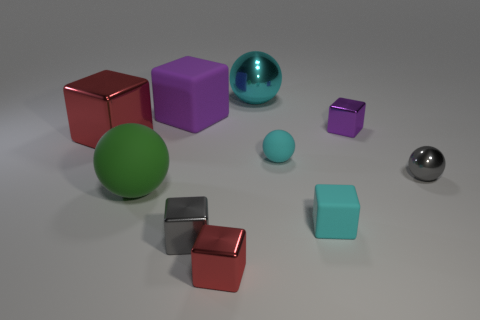Subtract all purple shiny blocks. How many blocks are left? 5 Subtract all green spheres. How many spheres are left? 3 Subtract 3 blocks. How many blocks are left? 3 Subtract all blocks. How many objects are left? 4 Subtract all red cylinders. How many gray blocks are left? 1 Add 8 cyan metallic things. How many cyan metallic things are left? 9 Add 8 purple balls. How many purple balls exist? 8 Subtract 0 blue cylinders. How many objects are left? 10 Subtract all green cubes. Subtract all gray balls. How many cubes are left? 6 Subtract all small red matte objects. Subtract all big purple blocks. How many objects are left? 9 